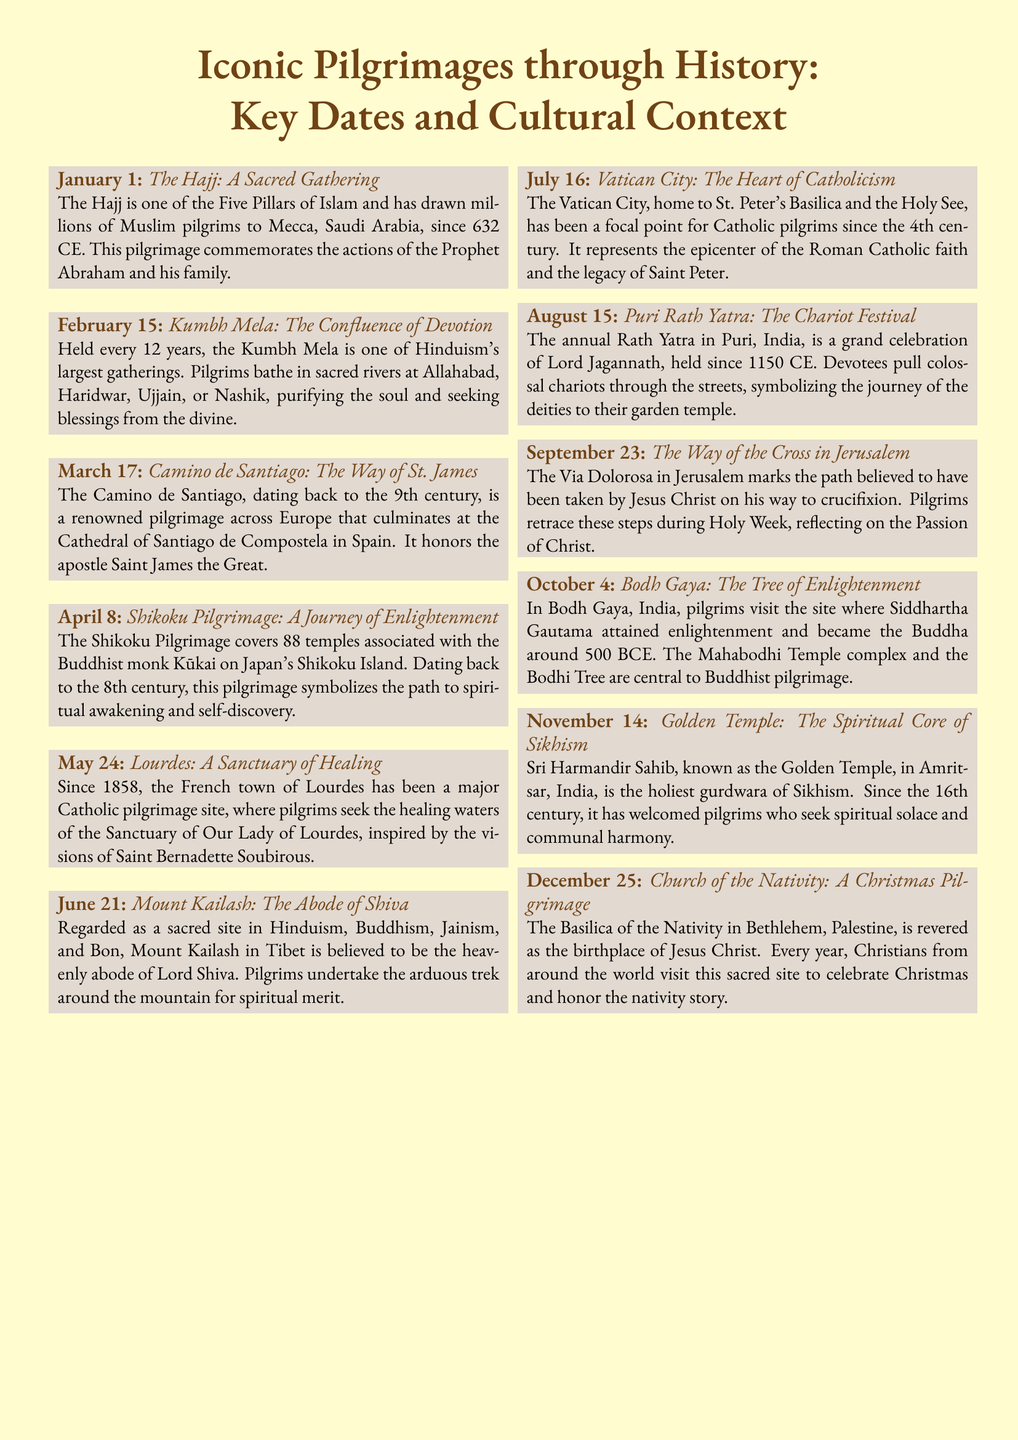what is the first pilgrimage listed in the document? The document lists "The Hajj: A Sacred Gathering" as the first pilgrimage entry for January 1.
Answer: The Hajj: A Sacred Gathering what date is the Kumbh Mela held? The Kumbh Mela occurs every 12 years, but the specific date mentioned in the document is February 15.
Answer: February 15 how many temples are associated with the Shikoku Pilgrimage? The Shikoku Pilgrimage features 88 temples, according to the description provided in the document.
Answer: 88 temples what is the significance of the Basilica of the Nativity? The Basilica of the Nativity is revered as the birthplace of Jesus Christ, and it is specifically noted in the document under December 25.
Answer: Birthplace of Jesus Christ which pilgrimage site is known as the spiritual core of Sikhism? The Golden Temple, also known as Sri Harmandir Sahib, is recognized as the spiritual core of Sikhism in the document.
Answer: Golden Temple what does the annual Rath Yatra in Puri celebrate? The annual Rath Yatra celebrates Lord Jagannath, as mentioned in the document under August 15.
Answer: Lord Jagannath what is the common theme among the pilgrimages listed in the document? The common theme among the listed pilgrimages revolves around cultural, religious significance, and seeking spiritual enlightenment or healing.
Answer: Cultural and spiritual significance which pilgrimage is associated with the enlightenment of Siddhartha Gautama? The pilgrimage associated with Siddhartha Gautama's enlightenment is Bodh Gaya, as mentioned in the document under October 4.
Answer: Bodh Gaya 